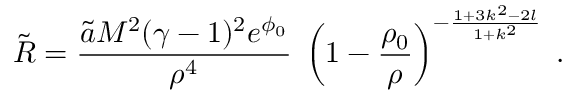<formula> <loc_0><loc_0><loc_500><loc_500>\tilde { R } = \frac { \tilde { a } M ^ { 2 } ( \gamma - 1 ) ^ { 2 } e ^ { \phi _ { 0 } } } { \rho ^ { 4 } } \, \left ( 1 - \frac { \rho _ { 0 } } { \rho } \right ) ^ { - \frac { 1 + 3 k ^ { 2 } - 2 l } { 1 + k ^ { 2 } } } \, .</formula> 